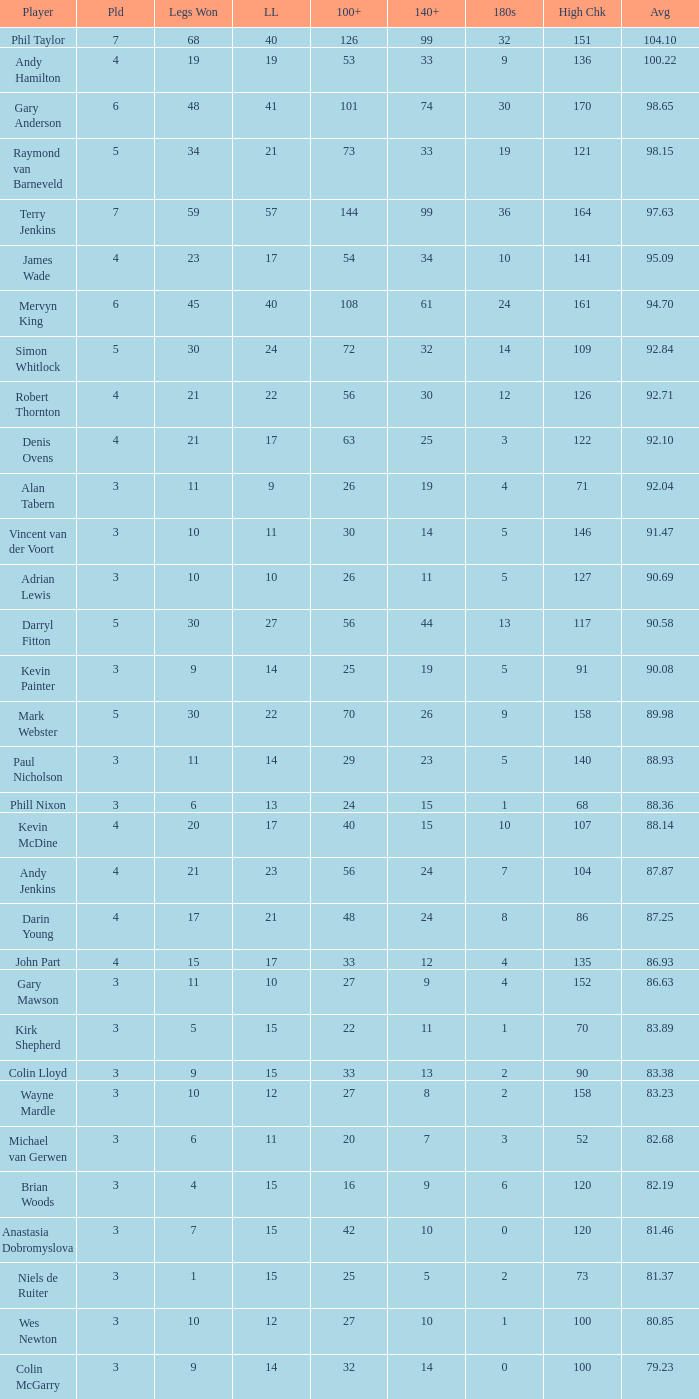Could you parse the entire table as a dict? {'header': ['Player', 'Pld', 'Legs Won', 'LL', '100+', '140+', '180s', 'High Chk', 'Avg'], 'rows': [['Phil Taylor', '7', '68', '40', '126', '99', '32', '151', '104.10'], ['Andy Hamilton', '4', '19', '19', '53', '33', '9', '136', '100.22'], ['Gary Anderson', '6', '48', '41', '101', '74', '30', '170', '98.65'], ['Raymond van Barneveld', '5', '34', '21', '73', '33', '19', '121', '98.15'], ['Terry Jenkins', '7', '59', '57', '144', '99', '36', '164', '97.63'], ['James Wade', '4', '23', '17', '54', '34', '10', '141', '95.09'], ['Mervyn King', '6', '45', '40', '108', '61', '24', '161', '94.70'], ['Simon Whitlock', '5', '30', '24', '72', '32', '14', '109', '92.84'], ['Robert Thornton', '4', '21', '22', '56', '30', '12', '126', '92.71'], ['Denis Ovens', '4', '21', '17', '63', '25', '3', '122', '92.10'], ['Alan Tabern', '3', '11', '9', '26', '19', '4', '71', '92.04'], ['Vincent van der Voort', '3', '10', '11', '30', '14', '5', '146', '91.47'], ['Adrian Lewis', '3', '10', '10', '26', '11', '5', '127', '90.69'], ['Darryl Fitton', '5', '30', '27', '56', '44', '13', '117', '90.58'], ['Kevin Painter', '3', '9', '14', '25', '19', '5', '91', '90.08'], ['Mark Webster', '5', '30', '22', '70', '26', '9', '158', '89.98'], ['Paul Nicholson', '3', '11', '14', '29', '23', '5', '140', '88.93'], ['Phill Nixon', '3', '6', '13', '24', '15', '1', '68', '88.36'], ['Kevin McDine', '4', '20', '17', '40', '15', '10', '107', '88.14'], ['Andy Jenkins', '4', '21', '23', '56', '24', '7', '104', '87.87'], ['Darin Young', '4', '17', '21', '48', '24', '8', '86', '87.25'], ['John Part', '4', '15', '17', '33', '12', '4', '135', '86.93'], ['Gary Mawson', '3', '11', '10', '27', '9', '4', '152', '86.63'], ['Kirk Shepherd', '3', '5', '15', '22', '11', '1', '70', '83.89'], ['Colin Lloyd', '3', '9', '15', '33', '13', '2', '90', '83.38'], ['Wayne Mardle', '3', '10', '12', '27', '8', '2', '158', '83.23'], ['Michael van Gerwen', '3', '6', '11', '20', '7', '3', '52', '82.68'], ['Brian Woods', '3', '4', '15', '16', '9', '6', '120', '82.19'], ['Anastasia Dobromyslova', '3', '7', '15', '42', '10', '0', '120', '81.46'], ['Niels de Ruiter', '3', '1', '15', '25', '5', '2', '73', '81.37'], ['Wes Newton', '3', '10', '12', '27', '10', '1', '100', '80.85'], ['Colin McGarry', '3', '9', '14', '32', '14', '0', '100', '79.23']]} What is the highest Legs Lost with a 180s larger than 1, a 100+ of 53, and played is smaller than 4? None. 